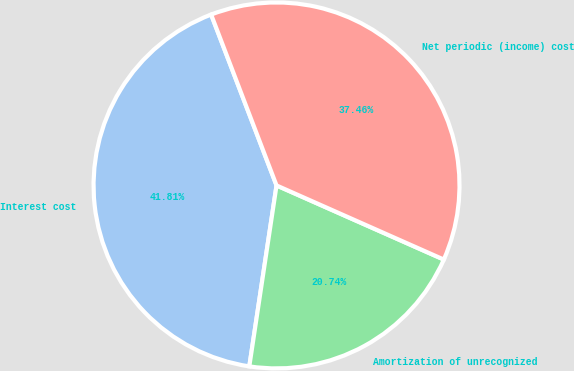<chart> <loc_0><loc_0><loc_500><loc_500><pie_chart><fcel>Interest cost<fcel>Amortization of unrecognized<fcel>Net periodic (income) cost<nl><fcel>41.81%<fcel>20.74%<fcel>37.46%<nl></chart> 